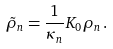<formula> <loc_0><loc_0><loc_500><loc_500>\tilde { \rho } _ { n } = \frac { 1 } { \kappa _ { n } } { K _ { 0 } } \rho _ { n } \, .</formula> 